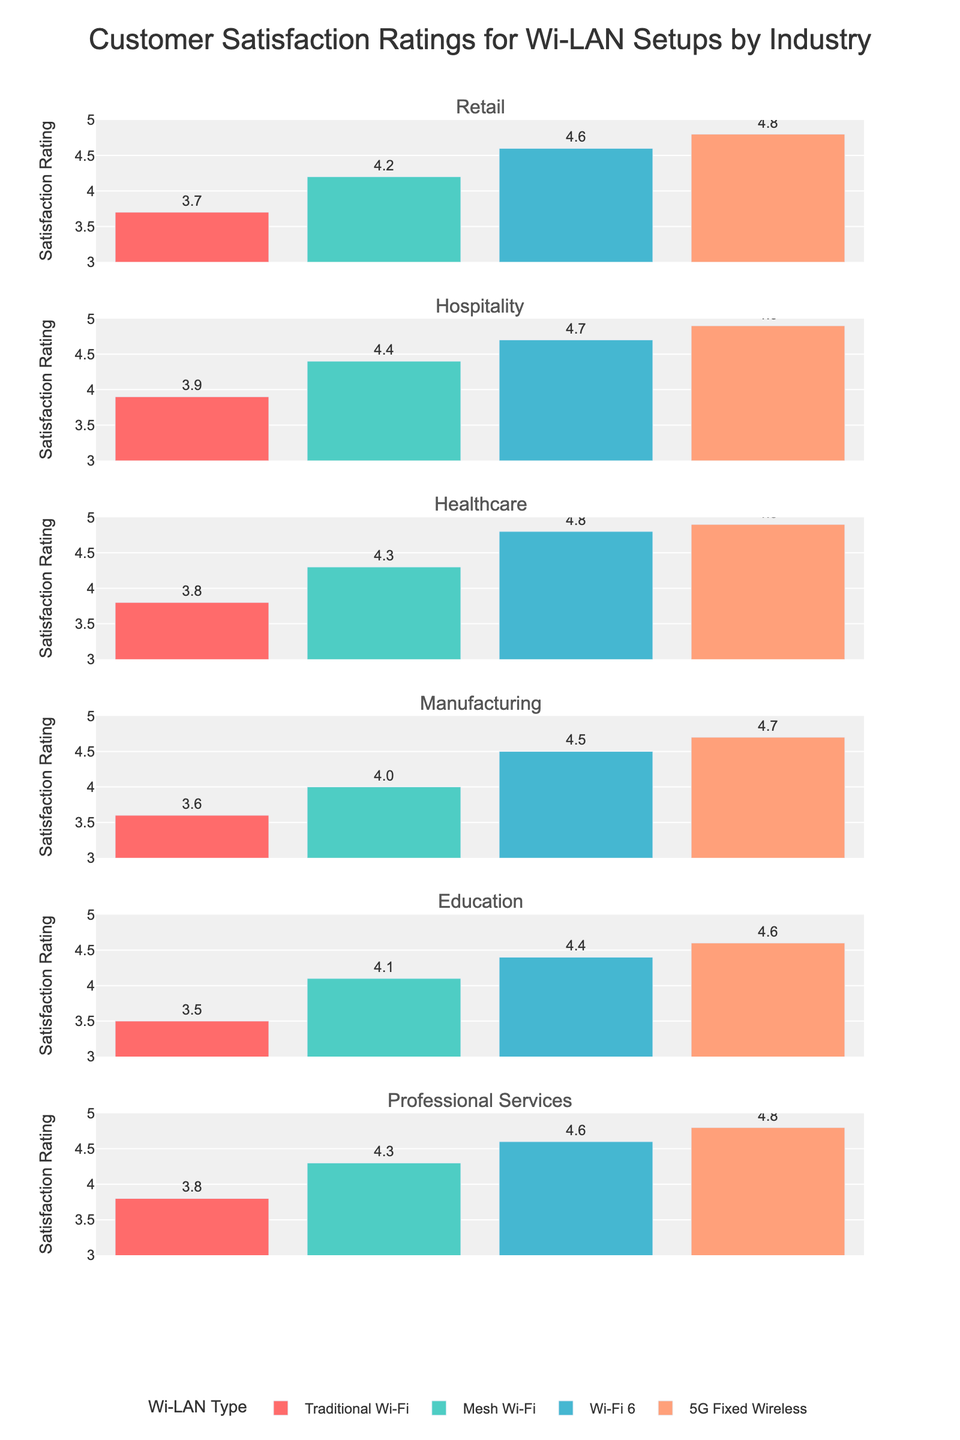What's the overall title of the figure? The overall title of the figure is usually found at the top center and is meant to describe the content of the plot. Looking at the figure, the bold text at the center top reads "Customer Satisfaction Ratings for Wi-LAN Setups by Industry".
Answer: Customer Satisfaction Ratings for Wi-LAN Setups by Industry Which Wi-LAN setup has the highest customer satisfaction rating in the Retail industry? To determine this, look at the bar heights for the Retail industry subplot. The highest bar corresponds to the "5G Fixed Wireless" setup, which has a rating of 4.8.
Answer: 5G Fixed Wireless What is the satisfaction rating range used in the y-axis? To find the y-axis range, check the left side of each subplot. The starting value is 3, and the maximum value is 5, as indicated by the ticks and grid lines.
Answer: 3 to 5 Which industry has the smallest difference in satisfaction ratings between "Traditional Wi-Fi" and "Wi-Fi 6"? Calculate the difference for each industry. Subtract "Traditional Wi-Fi" from "Wi-Fi 6" for each industry:
- Retail: 4.6 - 3.7 = 0.9
- Hospitality: 4.7 - 3.9 = 0.8
- Healthcare: 4.8 - 3.8 = 1.0
- Manufacturing: 4.5 - 3.6 = 0.9
- Education: 4.4 - 3.5 = 0.9
- Professional Services: 4.6 - 3.8 = 0.8
The smallest difference is found in the Hospitality and Professional Services industries, both at 0.8.
Answer: Hospitality, Professional Services Which Wi-LAN type consistently shows the highest satisfaction ratings across all industries? For each industry subplot, compare the bar heights of the four Wi-LAN types. The "5G Fixed Wireless" consistently has the highest rating in all industries.
Answer: 5G Fixed Wireless In the Manufacturing industry, what is the combined satisfaction rating for "Mesh Wi-Fi" and "Wi-Fi 6"? Look at the Manufacturing industry subplot: 
- Mesh Wi-Fi: 4.0
- Wi-Fi 6: 4.5
Summing them up, 4.0 + 4.5 = 8.5.
Answer: 8.5 Which industry has the highest average satisfaction rating across the four Wi-LAN setups? Calculate the average for each industry:
- Retail: (3.7 + 4.2 + 4.6 + 4.8) / 4 = 4.325
- Hospitality: (3.9 + 4.4 + 4.7 + 4.9) / 4 = 4.475
- Healthcare: (3.8 + 4.3 + 4.8 + 4.9) / 4 = 4.45
- Manufacturing: (3.6 + 4.0 + 4.5 + 4.7) / 4 = 4.2
- Education: (3.5 + 4.1 + 4.4 + 4.6) / 4 = 4.15
- Professional Services: (3.8 + 4.3 + 4.6 + 4.8) / 4 = 4.375
The highest average rating is found in the Hospitality industry, 4.475
Answer: Hospitality What is the satisfaction rating difference between "Traditional Wi-Fi" and "5G Fixed Wireless" in the Education industry? Look at the bars in the Education industry subplot:
- Traditional Wi-Fi: 3.5
- 5G Fixed Wireless: 4.6
The difference is 4.6 - 3.5 = 1.1.
Answer: 1.1 